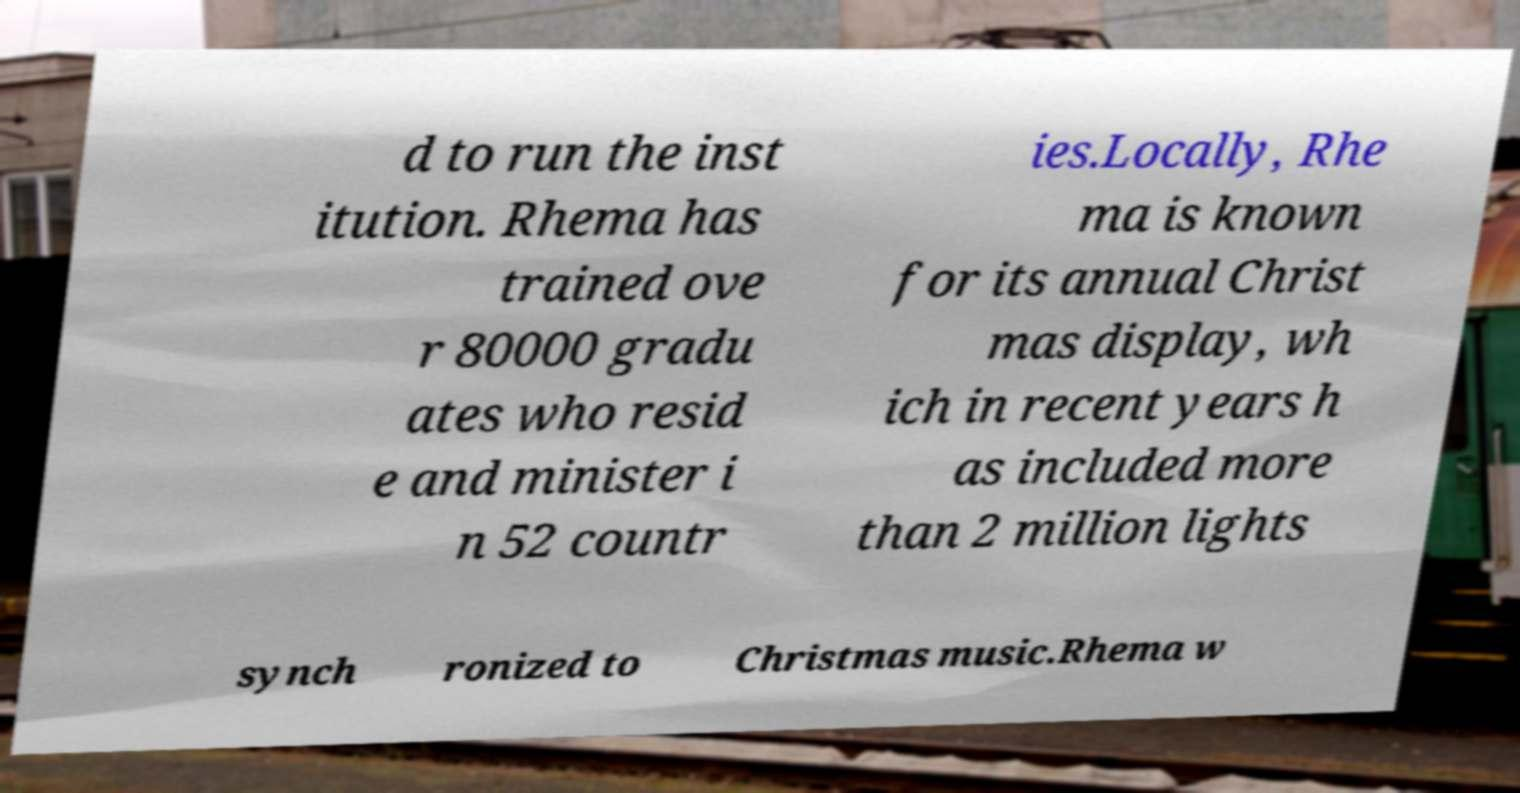Please read and relay the text visible in this image. What does it say? d to run the inst itution. Rhema has trained ove r 80000 gradu ates who resid e and minister i n 52 countr ies.Locally, Rhe ma is known for its annual Christ mas display, wh ich in recent years h as included more than 2 million lights synch ronized to Christmas music.Rhema w 